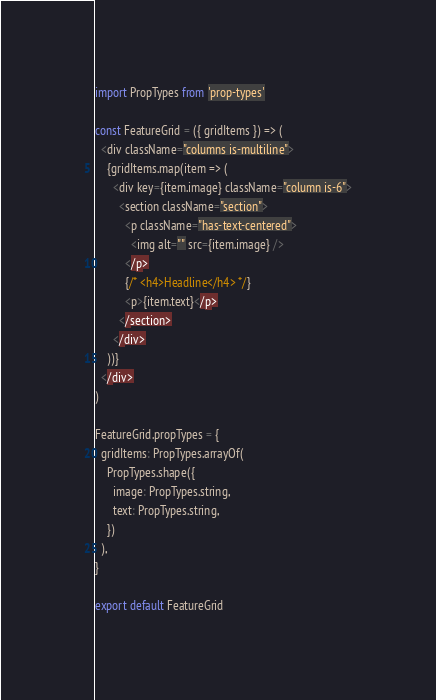Convert code to text. <code><loc_0><loc_0><loc_500><loc_500><_JavaScript_>import PropTypes from 'prop-types'

const FeatureGrid = ({ gridItems }) => (
  <div className="columns is-multiline">
    {gridItems.map(item => (
      <div key={item.image} className="column is-6">
        <section className="section">
          <p className="has-text-centered">
            <img alt="" src={item.image} />
          </p>
          {/* <h4>Headline</h4> */}
          <p>{item.text}</p>
        </section>
      </div>
    ))}
  </div>
)

FeatureGrid.propTypes = {
  gridItems: PropTypes.arrayOf(
    PropTypes.shape({
      image: PropTypes.string,
      text: PropTypes.string,
    })
  ),
}

export default FeatureGrid
</code> 